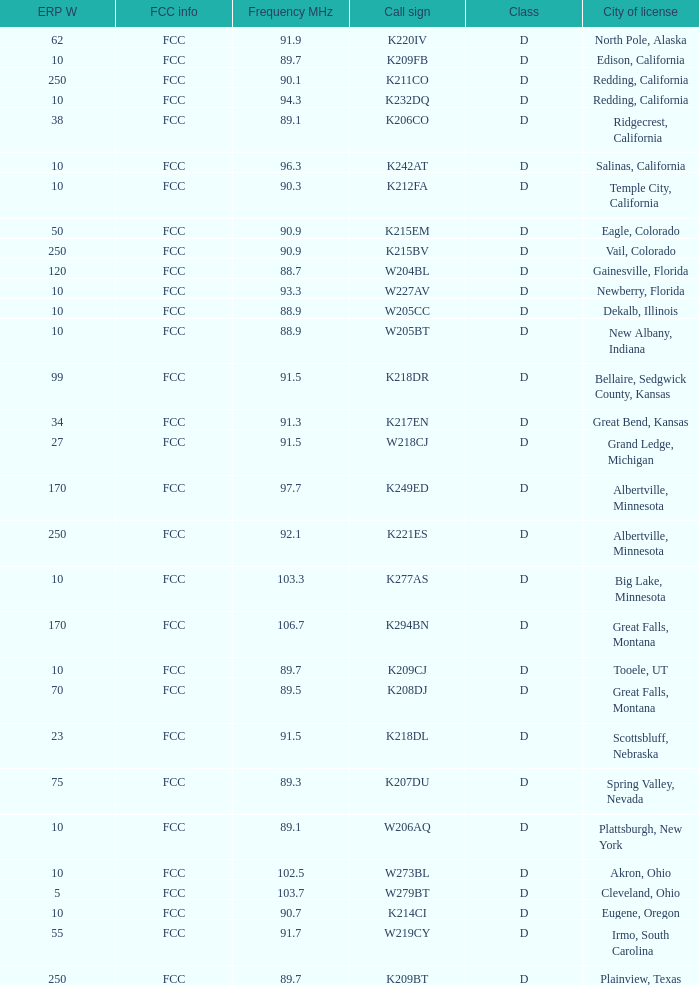What is the class of the translator with 10 ERP W and a call sign of w273bl? D. I'm looking to parse the entire table for insights. Could you assist me with that? {'header': ['ERP W', 'FCC info', 'Frequency MHz', 'Call sign', 'Class', 'City of license'], 'rows': [['62', 'FCC', '91.9', 'K220IV', 'D', 'North Pole, Alaska'], ['10', 'FCC', '89.7', 'K209FB', 'D', 'Edison, California'], ['250', 'FCC', '90.1', 'K211CO', 'D', 'Redding, California'], ['10', 'FCC', '94.3', 'K232DQ', 'D', 'Redding, California'], ['38', 'FCC', '89.1', 'K206CO', 'D', 'Ridgecrest, California'], ['10', 'FCC', '96.3', 'K242AT', 'D', 'Salinas, California'], ['10', 'FCC', '90.3', 'K212FA', 'D', 'Temple City, California'], ['50', 'FCC', '90.9', 'K215EM', 'D', 'Eagle, Colorado'], ['250', 'FCC', '90.9', 'K215BV', 'D', 'Vail, Colorado'], ['120', 'FCC', '88.7', 'W204BL', 'D', 'Gainesville, Florida'], ['10', 'FCC', '93.3', 'W227AV', 'D', 'Newberry, Florida'], ['10', 'FCC', '88.9', 'W205CC', 'D', 'Dekalb, Illinois'], ['10', 'FCC', '88.9', 'W205BT', 'D', 'New Albany, Indiana'], ['99', 'FCC', '91.5', 'K218DR', 'D', 'Bellaire, Sedgwick County, Kansas'], ['34', 'FCC', '91.3', 'K217EN', 'D', 'Great Bend, Kansas'], ['27', 'FCC', '91.5', 'W218CJ', 'D', 'Grand Ledge, Michigan'], ['170', 'FCC', '97.7', 'K249ED', 'D', 'Albertville, Minnesota'], ['250', 'FCC', '92.1', 'K221ES', 'D', 'Albertville, Minnesota'], ['10', 'FCC', '103.3', 'K277AS', 'D', 'Big Lake, Minnesota'], ['170', 'FCC', '106.7', 'K294BN', 'D', 'Great Falls, Montana'], ['10', 'FCC', '89.7', 'K209CJ', 'D', 'Tooele, UT'], ['70', 'FCC', '89.5', 'K208DJ', 'D', 'Great Falls, Montana'], ['23', 'FCC', '91.5', 'K218DL', 'D', 'Scottsbluff, Nebraska'], ['75', 'FCC', '89.3', 'K207DU', 'D', 'Spring Valley, Nevada'], ['10', 'FCC', '89.1', 'W206AQ', 'D', 'Plattsburgh, New York'], ['10', 'FCC', '102.5', 'W273BL', 'D', 'Akron, Ohio'], ['5', 'FCC', '103.7', 'W279BT', 'D', 'Cleveland, Ohio'], ['10', 'FCC', '90.7', 'K214CI', 'D', 'Eugene, Oregon'], ['55', 'FCC', '91.7', 'W219CY', 'D', 'Irmo, South Carolina'], ['250', 'FCC', '89.7', 'K209BT', 'D', 'Plainview, Texas']]} 